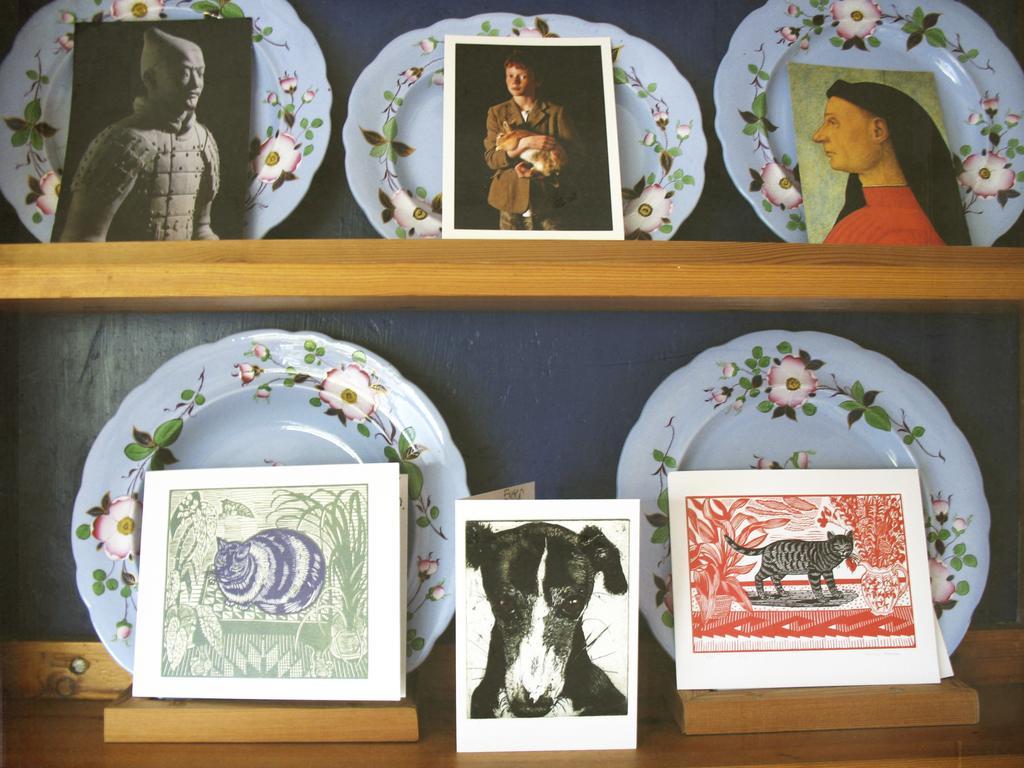Can you describe this image briefly? In this picture I can see there are plates and photographs on the shelves. 